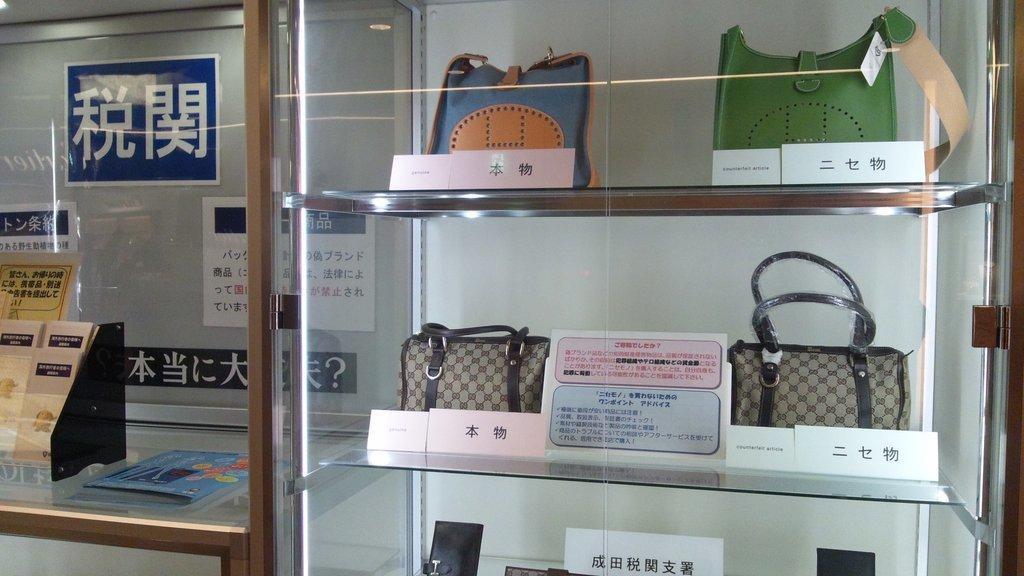Could you give a brief overview of what you see in this image? In this image there is a rack and we can see handbags placed in the rack. There are boards. On the left we can see a countertop. There are things placed on the countertop. 